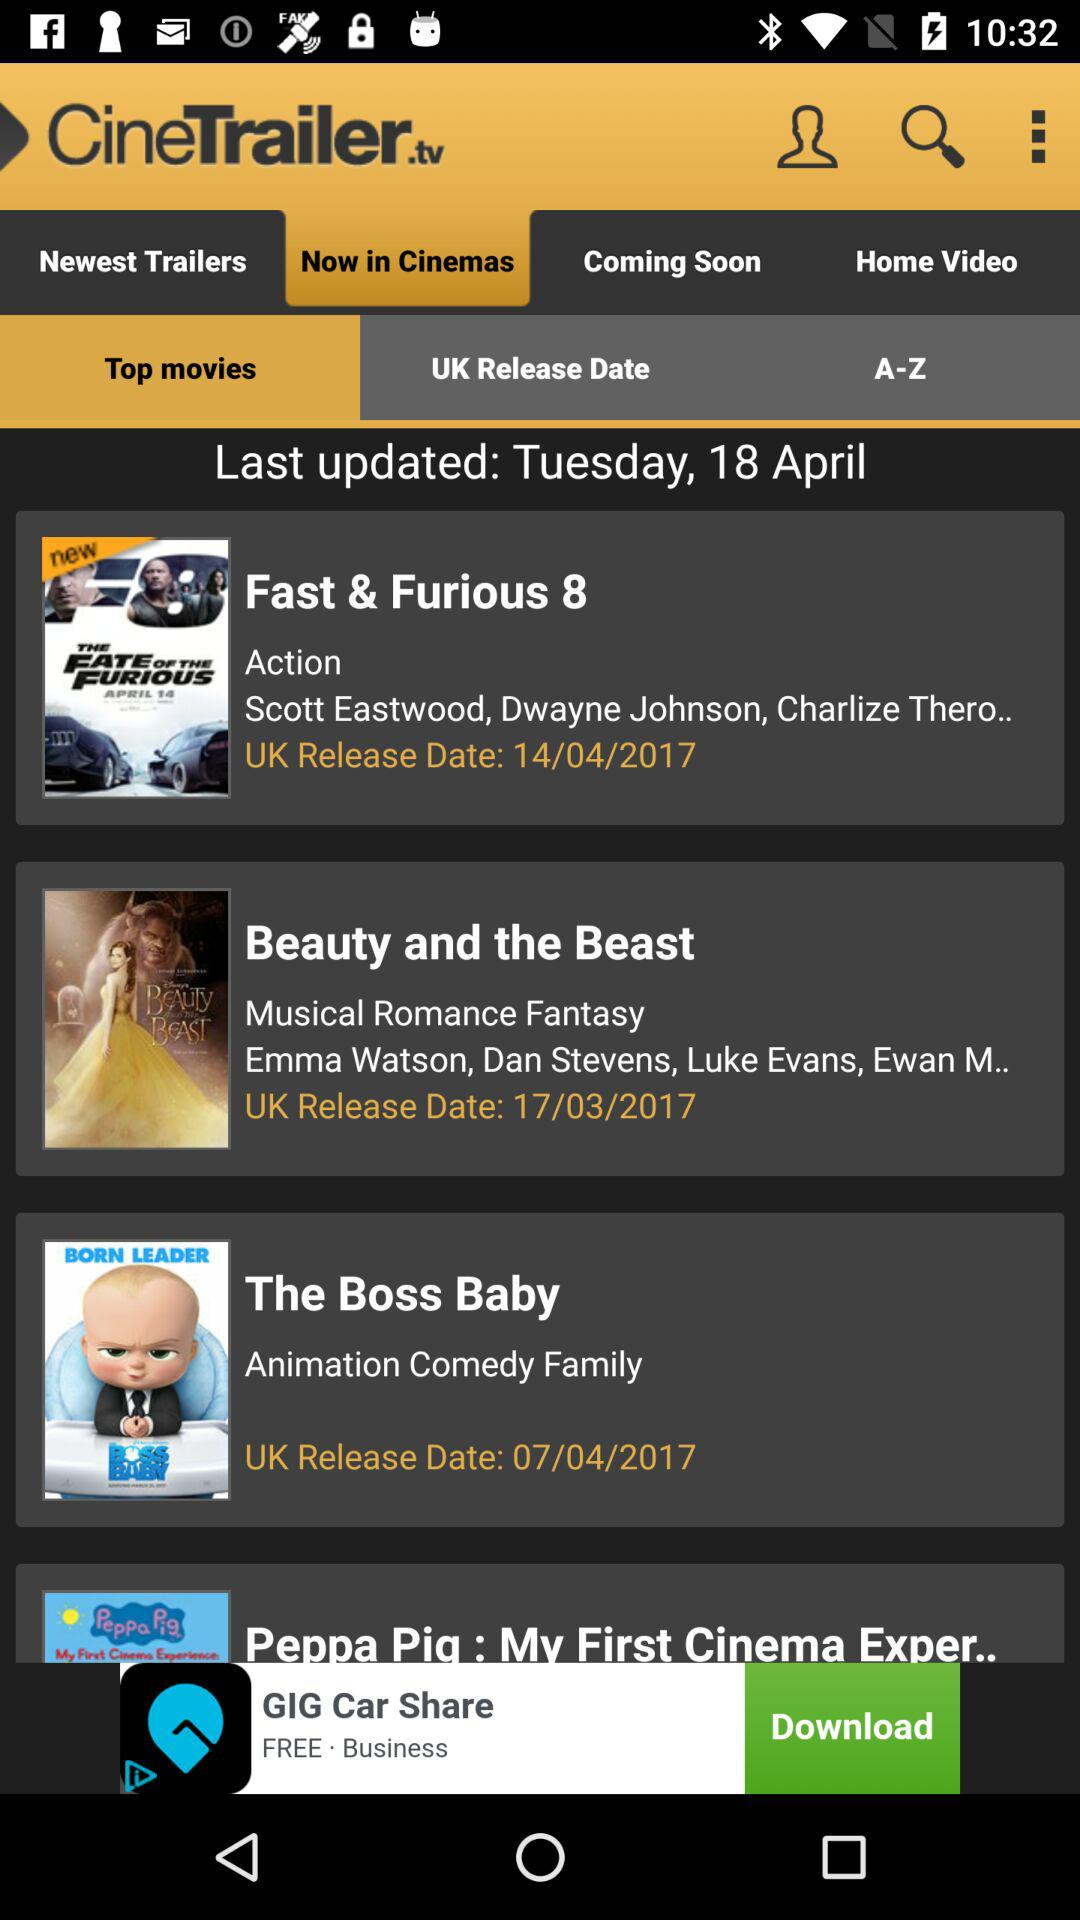On what date was it last updated? It was last updated on Tuesday, April 18. 